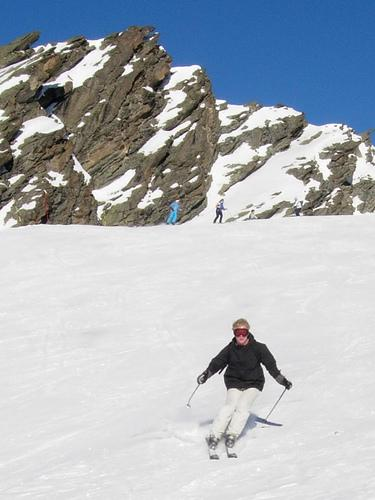What is the geological rock formation called? Please explain your reasoning. outcrop. In the foreground there is a visible exposure of bedrock.  this is also referred to as an outcrop. 